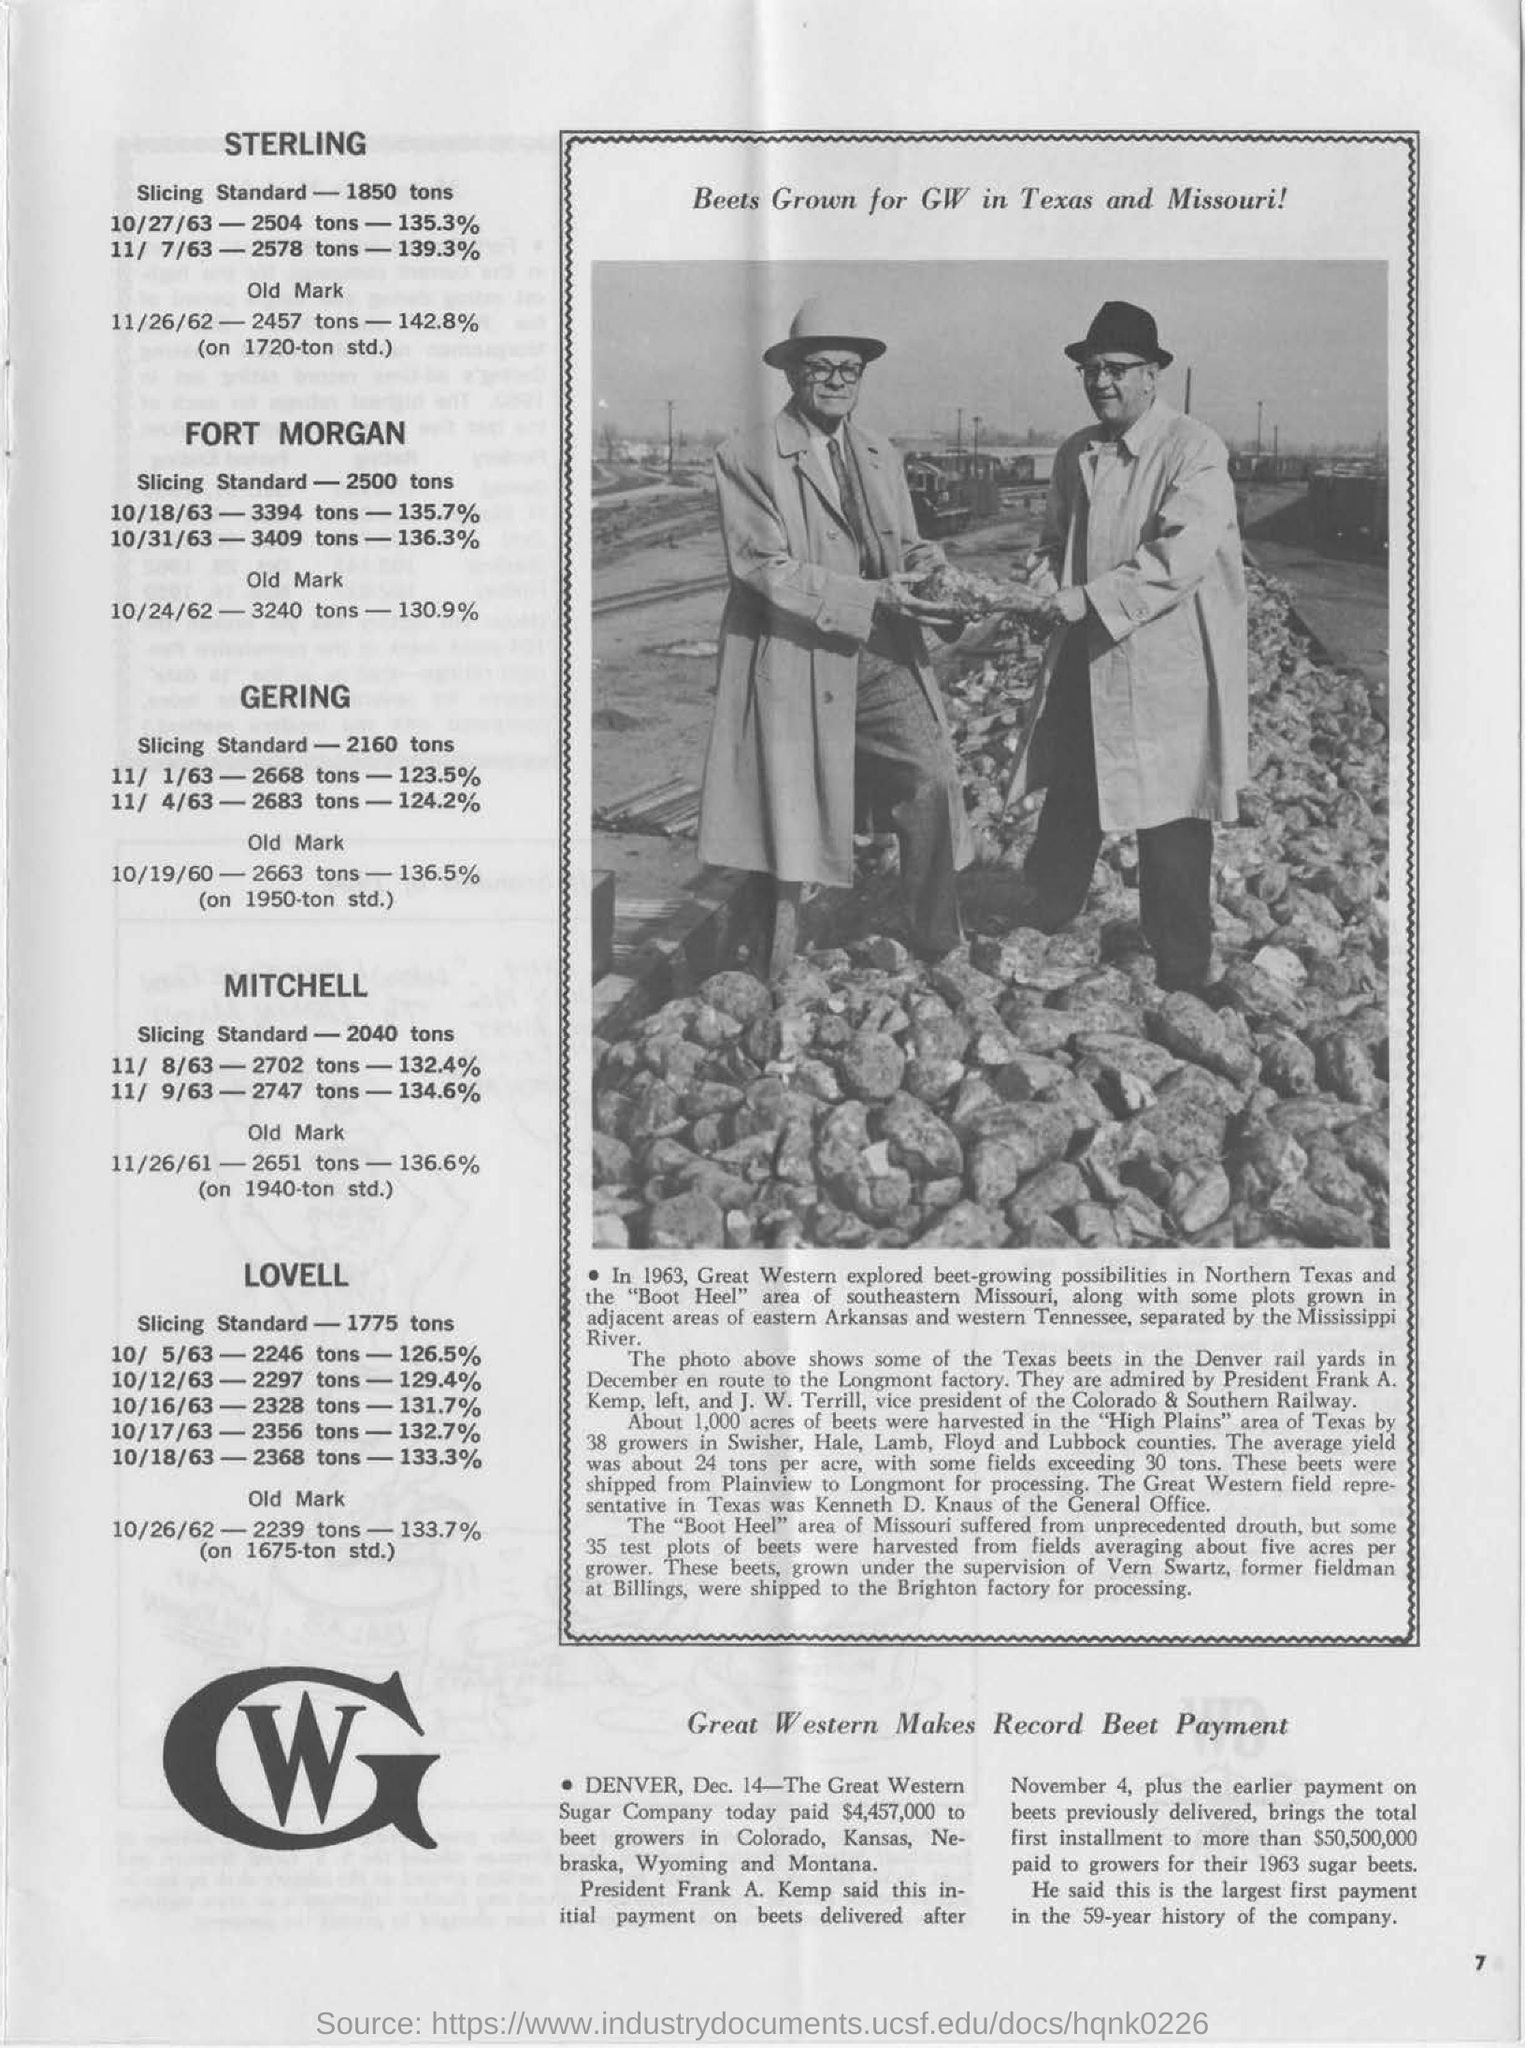Highlight a few significant elements in this photo. John W. Terrill is the Vice President of the Colorado & Southern Railway. The slicing standard for "gering" is 2160 tons. The individuals in the photograph are Frank A. Kemp and J. W. Terrill. The slicing standard for "Sterling" is 1850 tons. Frank A. Kemp is the President. 